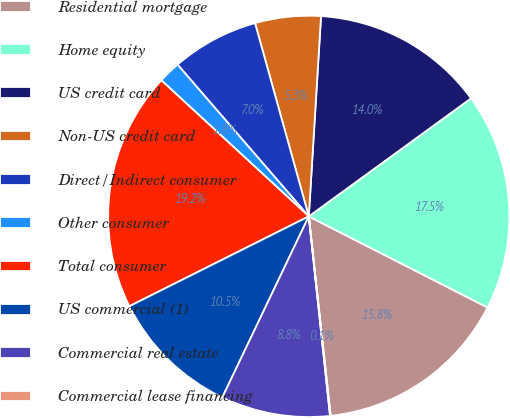Convert chart. <chart><loc_0><loc_0><loc_500><loc_500><pie_chart><fcel>Residential mortgage<fcel>Home equity<fcel>US credit card<fcel>Non-US credit card<fcel>Direct/Indirect consumer<fcel>Other consumer<fcel>Total consumer<fcel>US commercial (1)<fcel>Commercial real estate<fcel>Commercial lease financing<nl><fcel>15.76%<fcel>17.51%<fcel>14.02%<fcel>5.29%<fcel>7.03%<fcel>1.79%<fcel>19.25%<fcel>10.52%<fcel>8.78%<fcel>0.05%<nl></chart> 